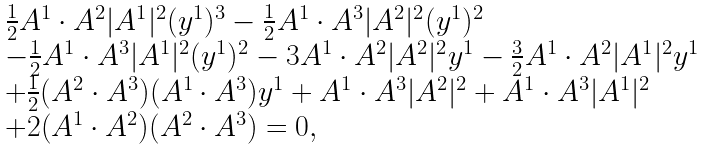Convert formula to latex. <formula><loc_0><loc_0><loc_500><loc_500>\begin{array} { l l l } \frac { 1 } { 2 } A ^ { 1 } \cdot A ^ { 2 } | A ^ { 1 } | ^ { 2 } ( y ^ { 1 } ) ^ { 3 } - \frac { 1 } { 2 } A ^ { 1 } \cdot A ^ { 3 } | A ^ { 2 } | ^ { 2 } ( y ^ { 1 } ) ^ { 2 } \\ - \frac { 1 } { 2 } A ^ { 1 } \cdot A ^ { 3 } | A ^ { 1 } | ^ { 2 } ( y ^ { 1 } ) ^ { 2 } - 3 A ^ { 1 } \cdot A ^ { 2 } | A ^ { 2 } | ^ { 2 } y ^ { 1 } - \frac { 3 } { 2 } A ^ { 1 } \cdot A ^ { 2 } | A ^ { 1 } | ^ { 2 } y ^ { 1 } \\ + \frac { 1 } { 2 } ( A ^ { 2 } \cdot A ^ { 3 } ) ( A ^ { 1 } \cdot A ^ { 3 } ) y ^ { 1 } + A ^ { 1 } \cdot A ^ { 3 } | A ^ { 2 } | ^ { 2 } + A ^ { 1 } \cdot A ^ { 3 } | A ^ { 1 } | ^ { 2 } \\ + 2 ( A ^ { 1 } \cdot A ^ { 2 } ) ( A ^ { 2 } \cdot A ^ { 3 } ) = 0 , \\ \end{array}</formula> 